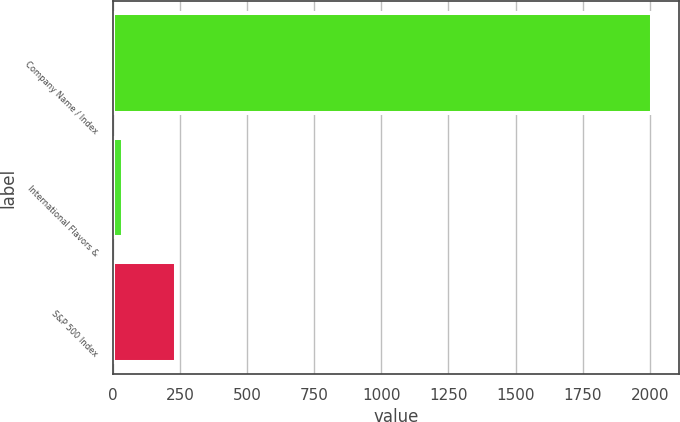Convert chart to OTSL. <chart><loc_0><loc_0><loc_500><loc_500><bar_chart><fcel>Company Name / Index<fcel>International Flavors &<fcel>S&P 500 Index<nl><fcel>2008<fcel>36.64<fcel>233.78<nl></chart> 